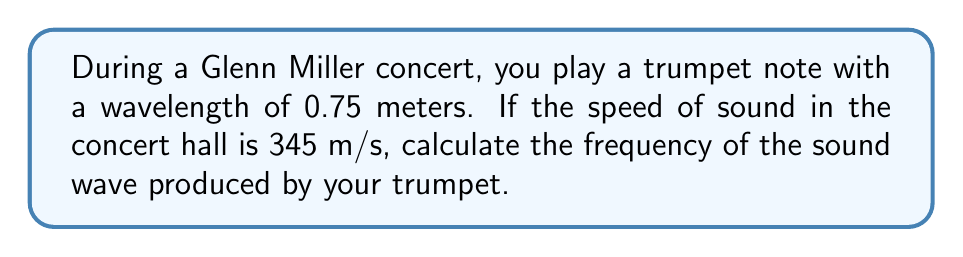What is the answer to this math problem? To solve this problem, we'll use the wave equation that relates wave speed, frequency, and wavelength:

$$ v = f \lambda $$

Where:
$v$ is the wave speed (in m/s)
$f$ is the frequency (in Hz)
$\lambda$ is the wavelength (in m)

We are given:
$v = 345$ m/s (speed of sound in the concert hall)
$\lambda = 0.75$ m (wavelength of the trumpet note)

To find the frequency, we rearrange the equation to solve for $f$:

$$ f = \frac{v}{\lambda} $$

Now, we can substitute the known values:

$$ f = \frac{345 \text{ m/s}}{0.75 \text{ m}} $$

Calculating this:

$$ f = 460 \text{ Hz} $$

This frequency corresponds to approximately the note A4 (A above middle C) on the musical scale, which is a common note played on a trumpet.
Answer: 460 Hz 